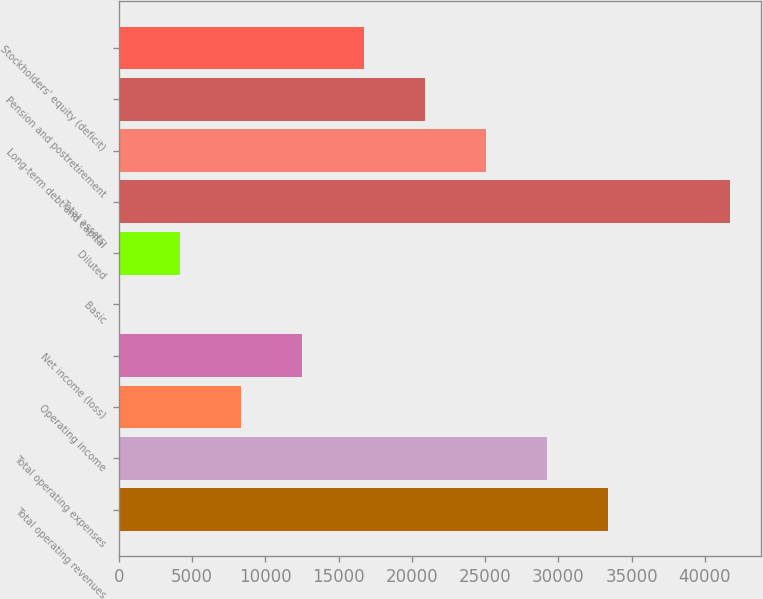Convert chart to OTSL. <chart><loc_0><loc_0><loc_500><loc_500><bar_chart><fcel>Total operating revenues<fcel>Total operating expenses<fcel>Operating income<fcel>Net income (loss)<fcel>Basic<fcel>Diluted<fcel>Total assets<fcel>Long-term debt and capital<fcel>Pension and postretirement<fcel>Stockholders' equity (deficit)<nl><fcel>33394.1<fcel>29220.7<fcel>8353.44<fcel>12526.9<fcel>6.54<fcel>4179.99<fcel>41741<fcel>25047.2<fcel>20873.8<fcel>16700.3<nl></chart> 